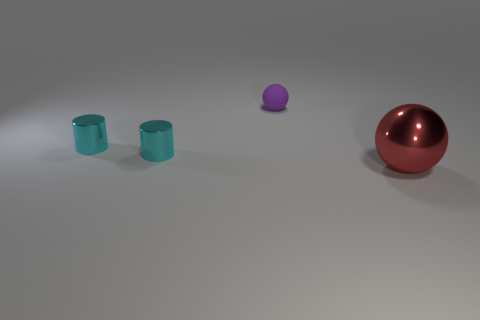Is the purple object made of the same material as the big sphere?
Provide a short and direct response. No. How many big red spheres are on the right side of the sphere that is to the right of the sphere to the left of the large shiny thing?
Provide a short and direct response. 0. There is another object that is the same shape as the large thing; what color is it?
Your response must be concise. Purple. Are there fewer tiny blue metallic things than cyan shiny cylinders?
Your answer should be compact. Yes. There is a ball in front of the purple matte sphere; what is its size?
Provide a succinct answer. Large. There is a red metallic thing that is the same shape as the tiny matte thing; what is its size?
Provide a short and direct response. Large. What number of small cylinders have the same material as the purple ball?
Ensure brevity in your answer.  0. Do the large shiny object and the sphere to the left of the large red shiny ball have the same color?
Give a very brief answer. No. Is the number of purple rubber things greater than the number of small objects?
Offer a terse response. No. What color is the matte sphere?
Keep it short and to the point. Purple. 